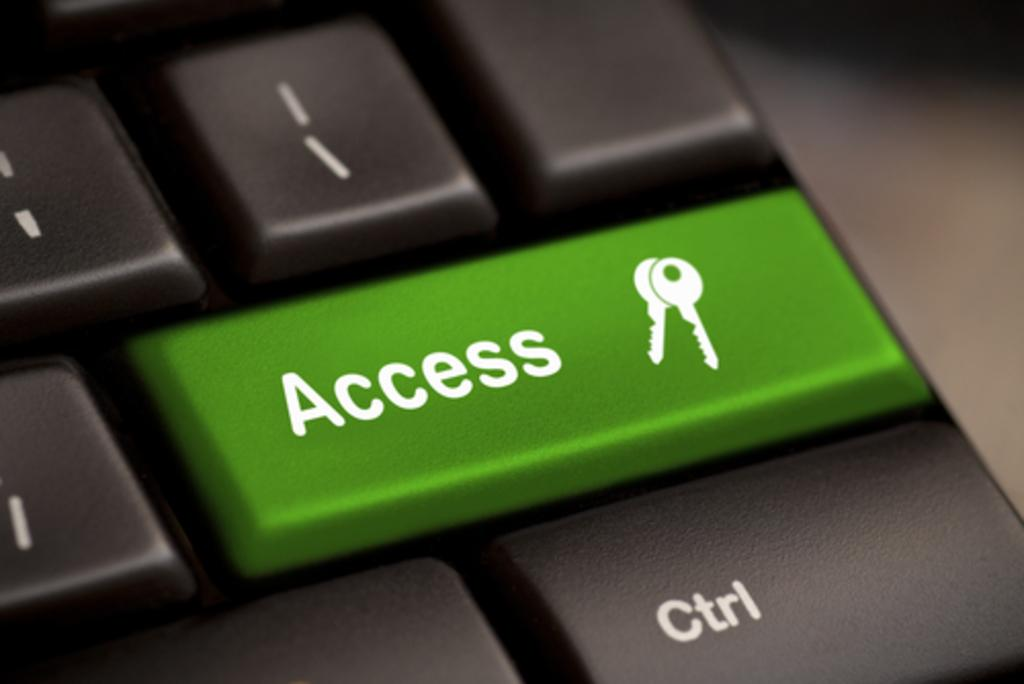<image>
Render a clear and concise summary of the photo. Large green access keyboard button with a key on it. 